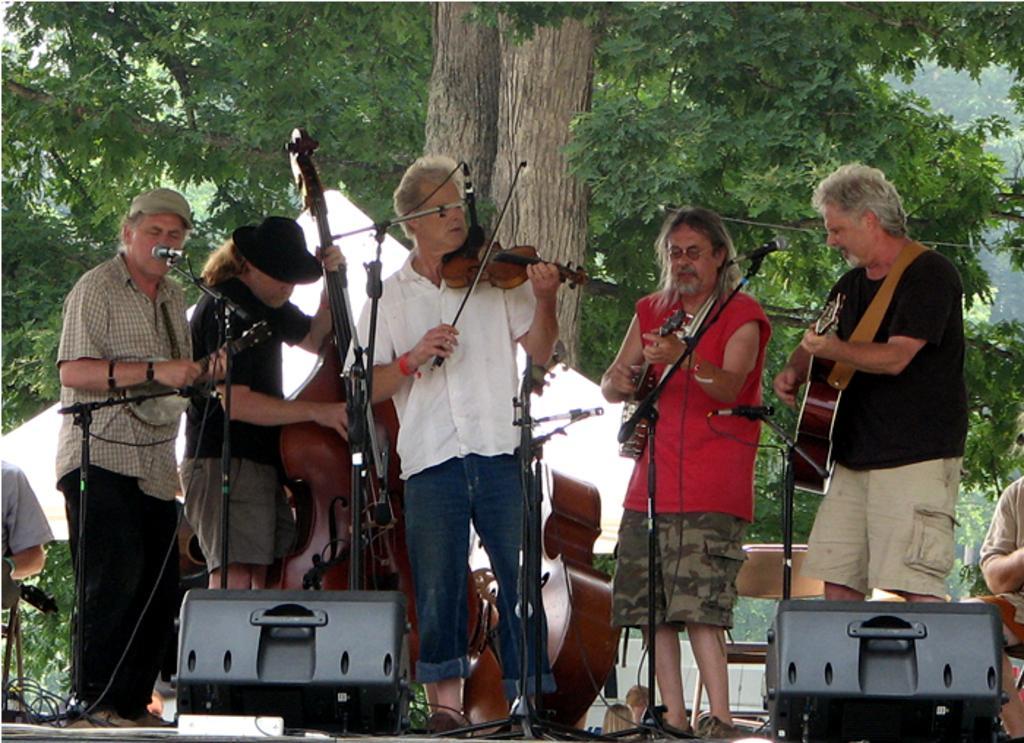Can you describe this image briefly? In this picture we can see a group people on the stage and some people holding the musical instruments. In front of the people there are stands, cables and some objects. Behind the people there are trees. 